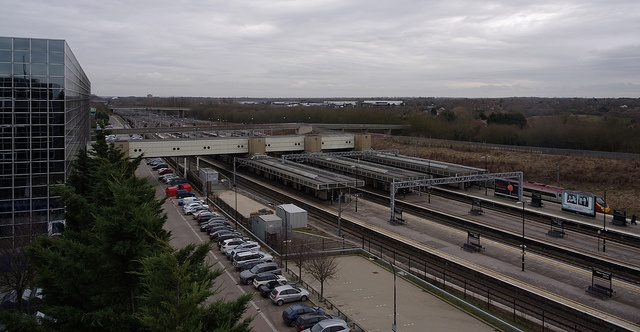Describe the objects in this image and their specific colors. I can see car in darkgray, black, and gray tones, car in darkgray, black, and gray tones, train in darkgray, black, gray, maroon, and brown tones, car in darkgray, black, and gray tones, and car in darkgray, black, and gray tones in this image. 